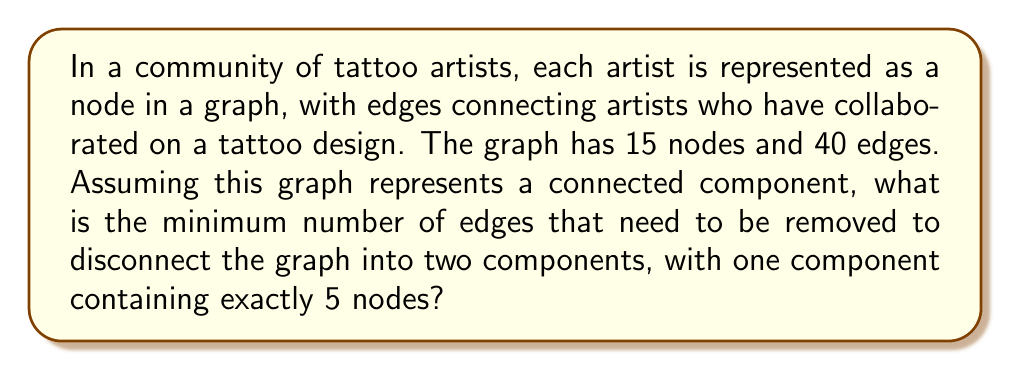Could you help me with this problem? To solve this problem, we need to understand the concept of edge connectivity in graph theory. The edge connectivity of a graph is the minimum number of edges that need to be removed to disconnect the graph.

Let's approach this step-by-step:

1) First, we need to consider the structure of the graph. We have:
   - 15 nodes (representing tattoo artists)
   - 40 edges (representing collaborations)
   - The graph is connected

2) We're asked to find the minimum number of edges to remove to create two components, with one component having exactly 5 nodes.

3) This scenario describes a cut set in graph theory. Specifically, we're looking for a minimum cut that separates 5 nodes from the rest of the graph.

4) In a connected graph, the minimum number of edges to disconnect the graph is always less than or equal to the minimum degree of any node. However, we don't have this information.

5) Instead, we can use the concept of maximum flow - minimum cut theorem. In this case, we're looking for the minimum number of edges that, when removed, will separate 5 nodes from the other 10.

6) Given that we don't have specific information about the graph structure beyond the number of nodes and edges, we need to consider the minimum possible cut.

7) The minimum cut would occur if the 5 nodes were connected to the rest of the graph in a "tree-like" manner, meaning with the minimum number of edges necessary to keep the graph connected.

8) The minimum number of edges to connect 5 nodes to the rest of the graph while keeping it connected is 1.

Therefore, the minimum number of edges that need to be removed to disconnect the graph into two components, with one component containing exactly 5 nodes, is 1.
Answer: 1 edge 